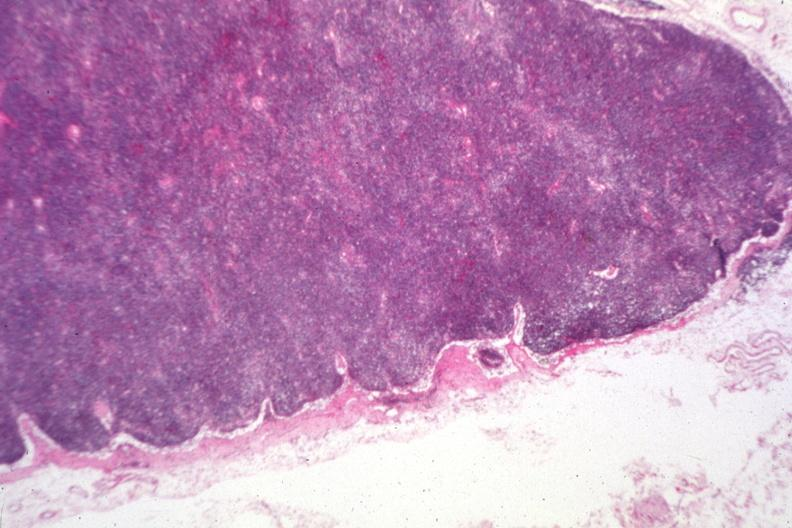s lymph node present?
Answer the question using a single word or phrase. Yes 